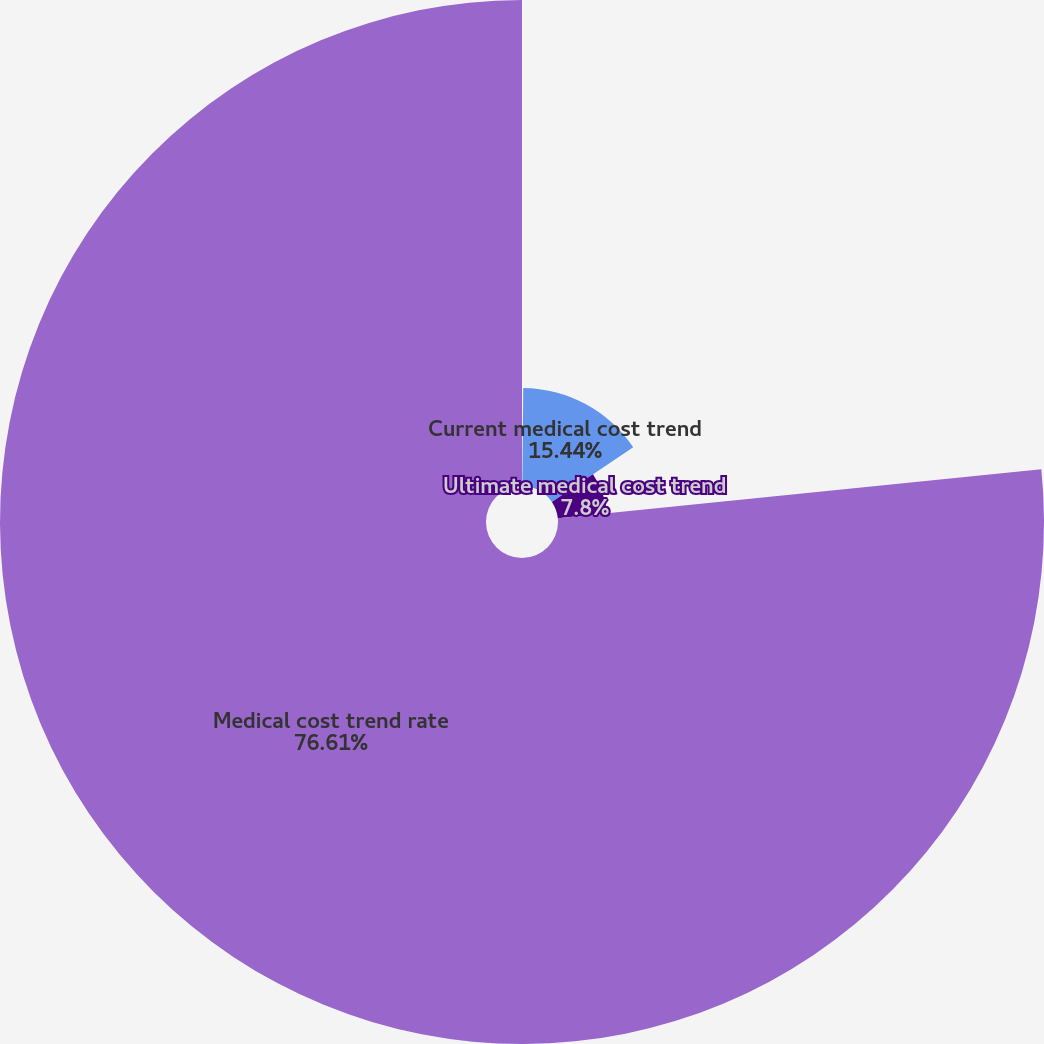Convert chart to OTSL. <chart><loc_0><loc_0><loc_500><loc_500><pie_chart><fcel>Discount rate<fcel>Current medical cost trend<fcel>Ultimate medical cost trend<fcel>Medical cost trend rate<nl><fcel>0.15%<fcel>15.44%<fcel>7.8%<fcel>76.61%<nl></chart> 